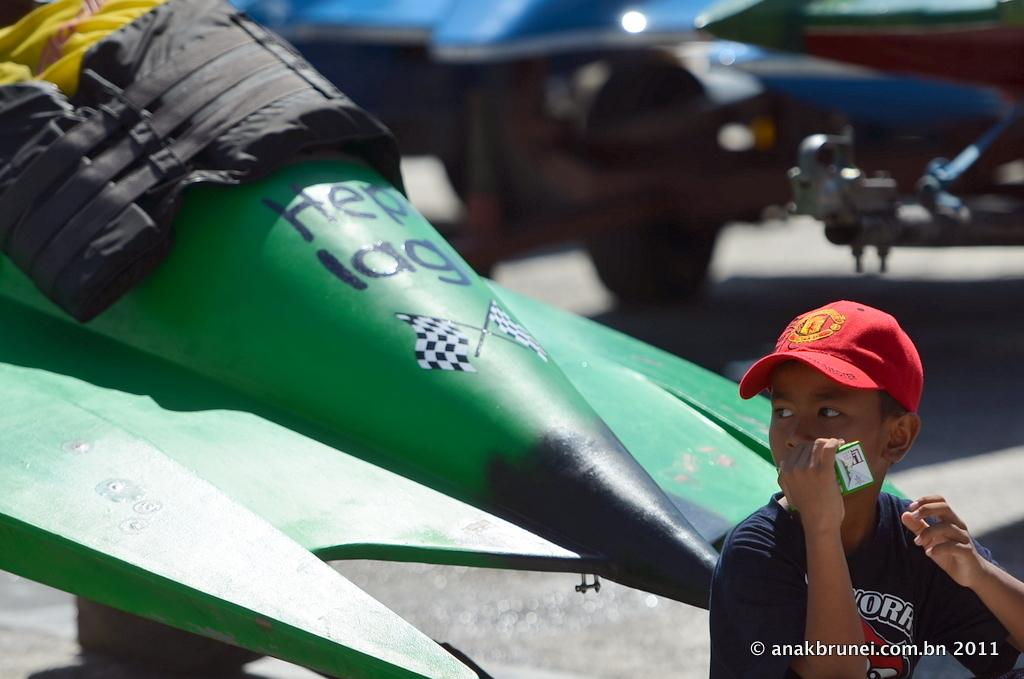Where is the boy located in the image? The boy is in the bottom right side of the image. What is the boy doing in the image? The boy is standing in the image. What is the boy holding in the image? The boy is holding something in the image. What can be seen behind the boy in the image? There is a vehicle behind the boy in the image. Can you see any monkeys on the island in the image? There is no island or monkey present in the image. Is there any sleet visible in the image? There is no mention of sleet or weather conditions in the provided facts, so it cannot be determined from the image. 